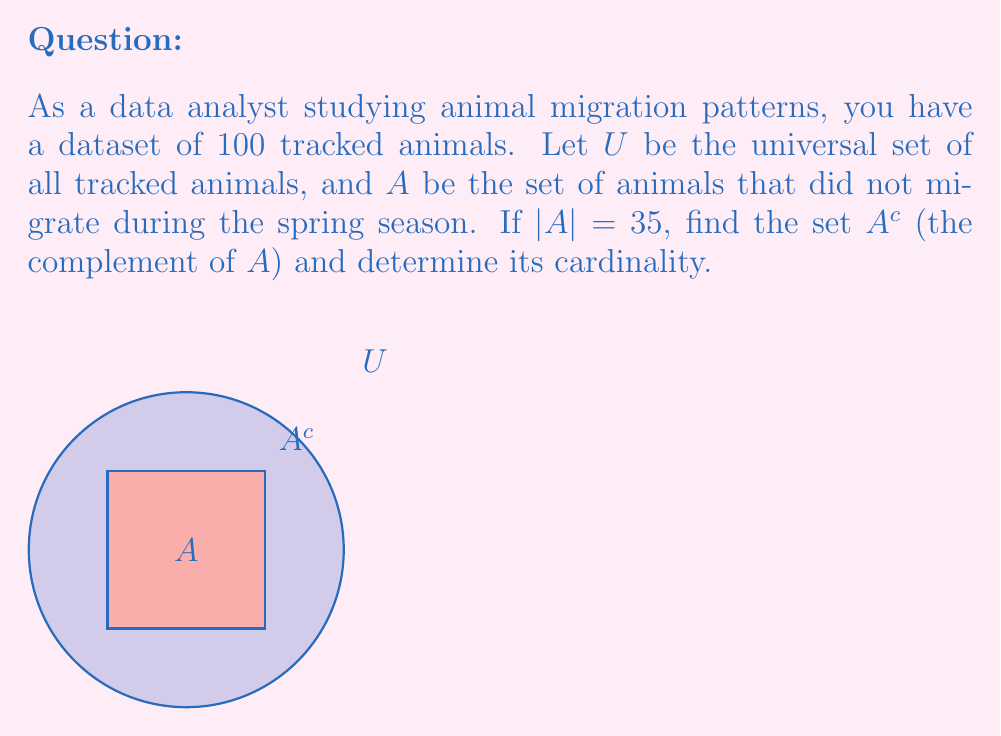Give your solution to this math problem. Let's approach this step-by-step:

1) First, recall that the complement of a set $A$, denoted as $A^c$, is the set of all elements in the universal set $U$ that are not in $A$.

2) We know that:
   - $U$ is the universal set of all tracked animals
   - $|U| = 100$ (total number of tracked animals)
   - $A$ is the set of animals that did not migrate
   - $|A| = 35$ (number of animals that did not migrate)

3) To find $A^c$, we need to identify all animals that did migrate. These are the animals in $U$ that are not in $A$.

4) The cardinality of $A^c$ can be calculated using the formula:
   
   $|A^c| = |U| - |A|$

5) Substituting the known values:
   
   $|A^c| = 100 - 35 = 65$

6) Therefore, $A^c$ is the set of 65 animals that did migrate during the spring season.

7) In set notation, we can express $A^c$ as:
   
   $A^c = \{x \in U : x \notin A\}$

   Which reads as "the set of all elements $x$ in $U$ such that $x$ is not in $A$".
Answer: $A^c = \{x \in U : x \notin A\}$, $|A^c| = 65$ 